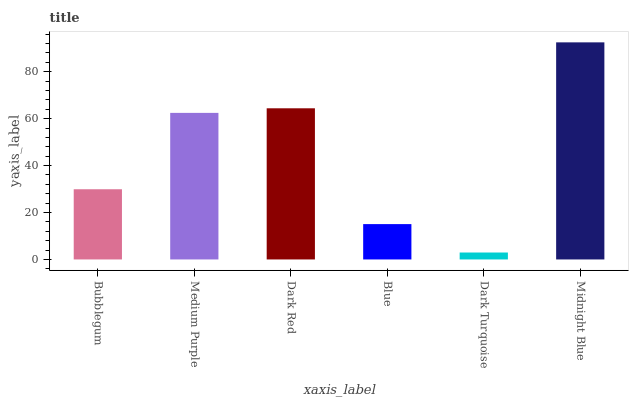Is Medium Purple the minimum?
Answer yes or no. No. Is Medium Purple the maximum?
Answer yes or no. No. Is Medium Purple greater than Bubblegum?
Answer yes or no. Yes. Is Bubblegum less than Medium Purple?
Answer yes or no. Yes. Is Bubblegum greater than Medium Purple?
Answer yes or no. No. Is Medium Purple less than Bubblegum?
Answer yes or no. No. Is Medium Purple the high median?
Answer yes or no. Yes. Is Bubblegum the low median?
Answer yes or no. Yes. Is Bubblegum the high median?
Answer yes or no. No. Is Medium Purple the low median?
Answer yes or no. No. 